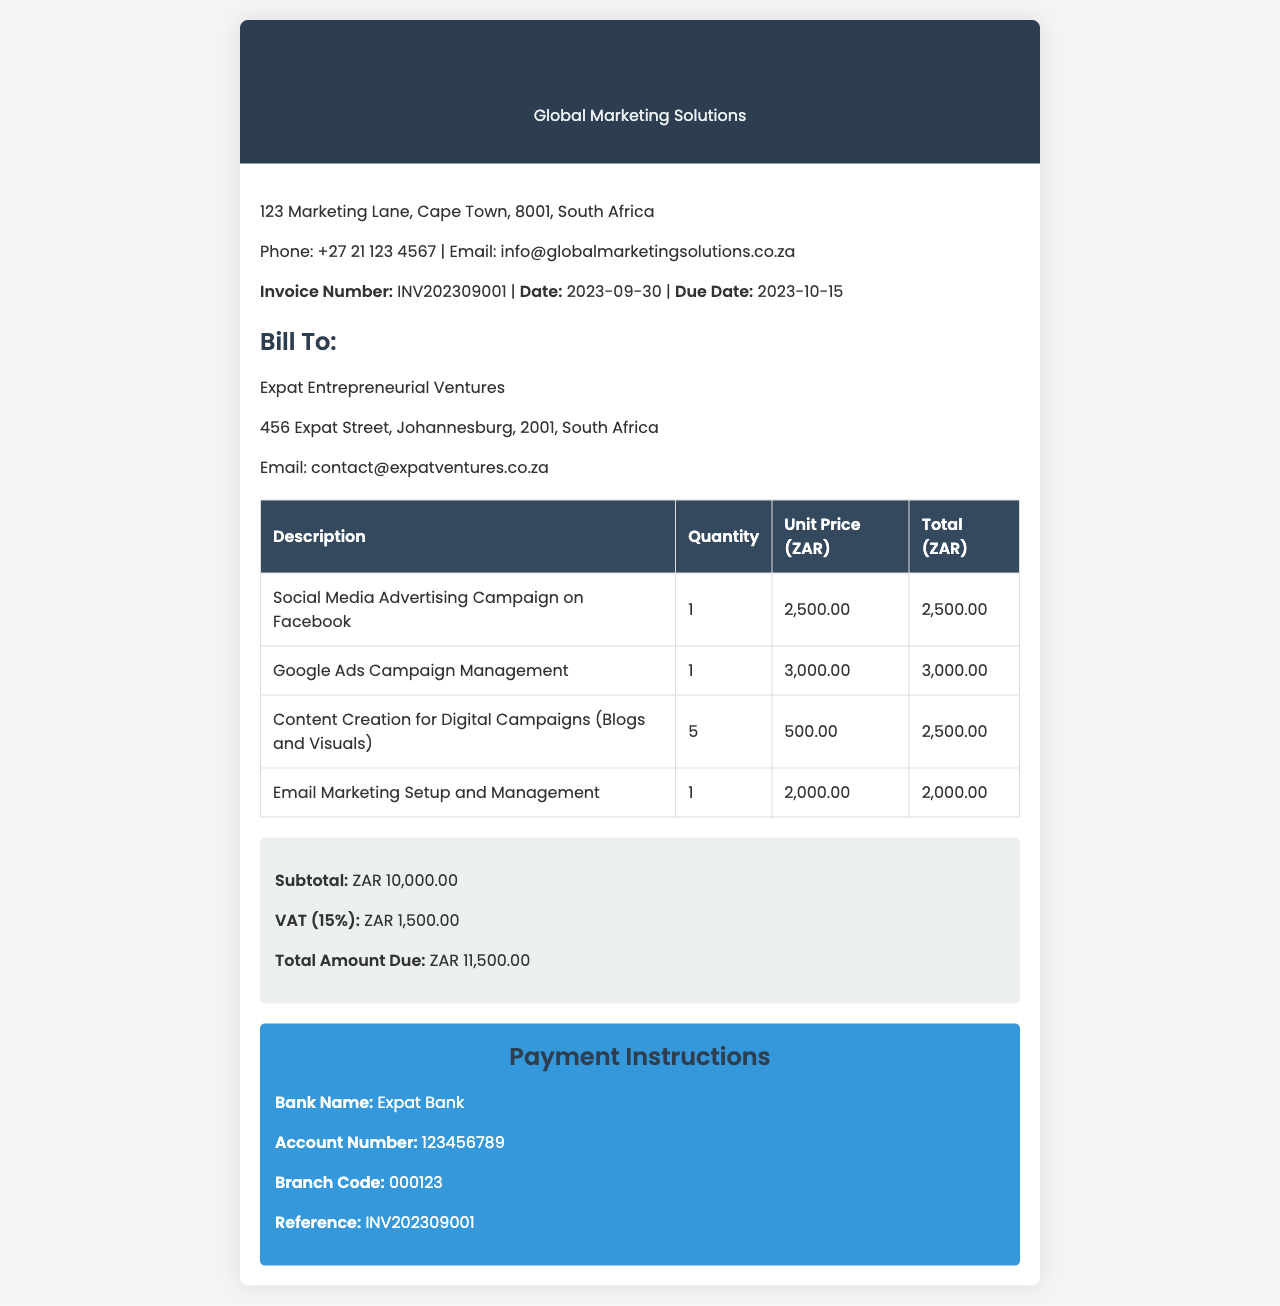What is the invoice number? The invoice number is a unique identifier for this document found in the company details section.
Answer: INV202309001 What is the total amount due? The total amount due is the final amount to be paid, calculated including VAT.
Answer: ZAR 11,500.00 What services were provided in September 2023? The services listed in the invoice detail the marketing activities performed during that month.
Answer: Social Media Advertising Campaign, Google Ads Campaign Management, Content Creation, Email Marketing Setup What is the VAT percentage included in the invoice? The VAT percentage is specified in the invoice summary section as part of the charge calculations.
Answer: 15% What is the due date for the invoice payment? The due date specifies when the payment must be completed, indicated in the company details.
Answer: 2023-10-15 What is the subtotal before VAT? The subtotal is the sum of all service costs before any taxes are applied, shown in the invoice summary.
Answer: ZAR 10,000.00 What is the payment reference specified? The payment reference is provided for making payments easier and ensuring they are properly attributed.
Answer: INV202309001 How many content creation items were billed? The quantity of the content creation items reflects the number of such services that were invoiced.
Answer: 5 What is the email address for Global Marketing Solutions? The email address is included in the company details for contact purposes.
Answer: info@globalmarketingsolutions.co.za 